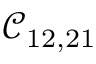<formula> <loc_0><loc_0><loc_500><loc_500>\mathcal { C } _ { 1 2 , 2 1 }</formula> 